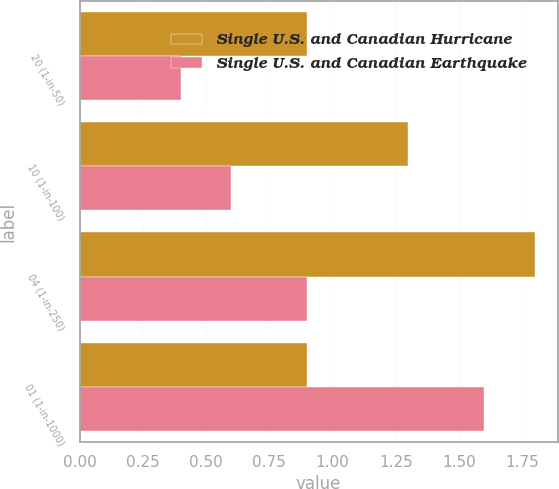<chart> <loc_0><loc_0><loc_500><loc_500><stacked_bar_chart><ecel><fcel>20 (1-in-50)<fcel>10 (1-in-100)<fcel>04 (1-in-250)<fcel>01 (1-in-1000)<nl><fcel>Single U.S. and Canadian Hurricane<fcel>0.9<fcel>1.3<fcel>1.8<fcel>0.9<nl><fcel>Single U.S. and Canadian Earthquake<fcel>0.4<fcel>0.6<fcel>0.9<fcel>1.6<nl></chart> 